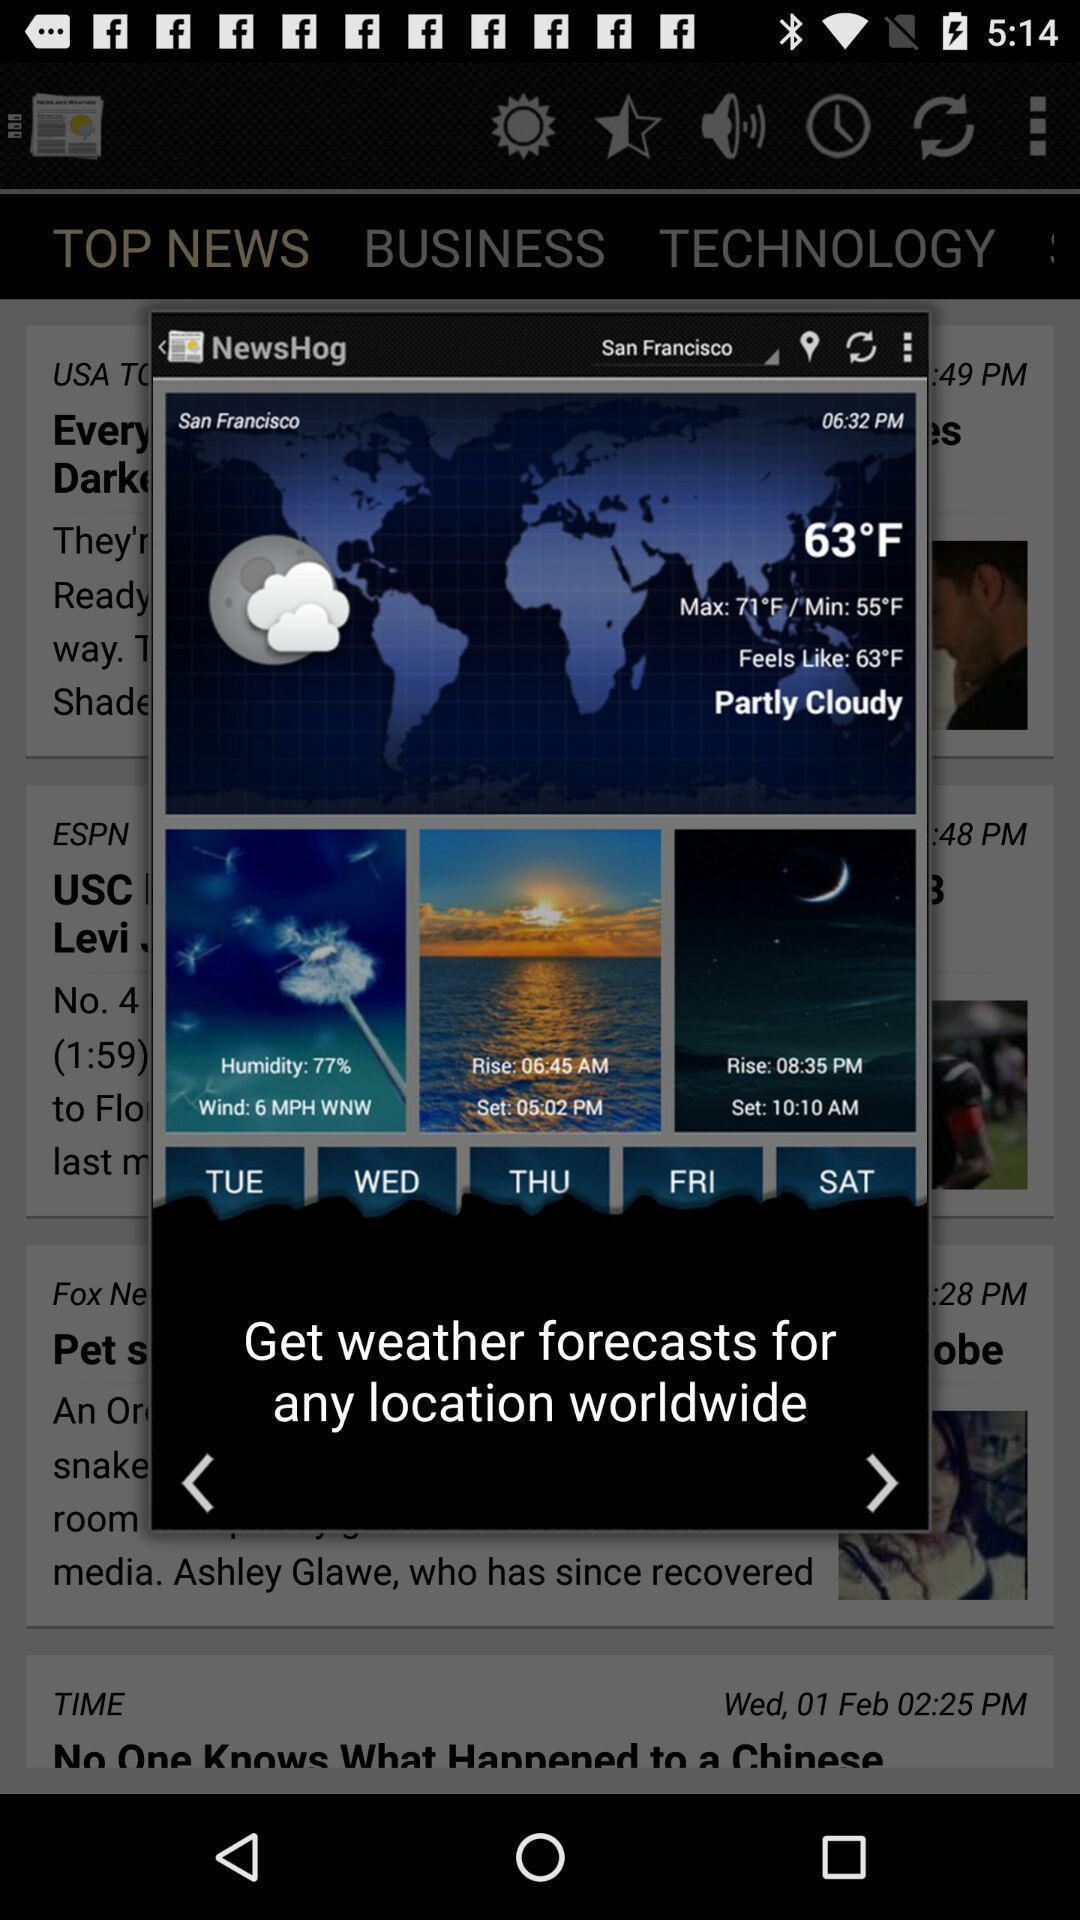What is the overall content of this screenshot? Pop up displaying the information about weather forecast. 